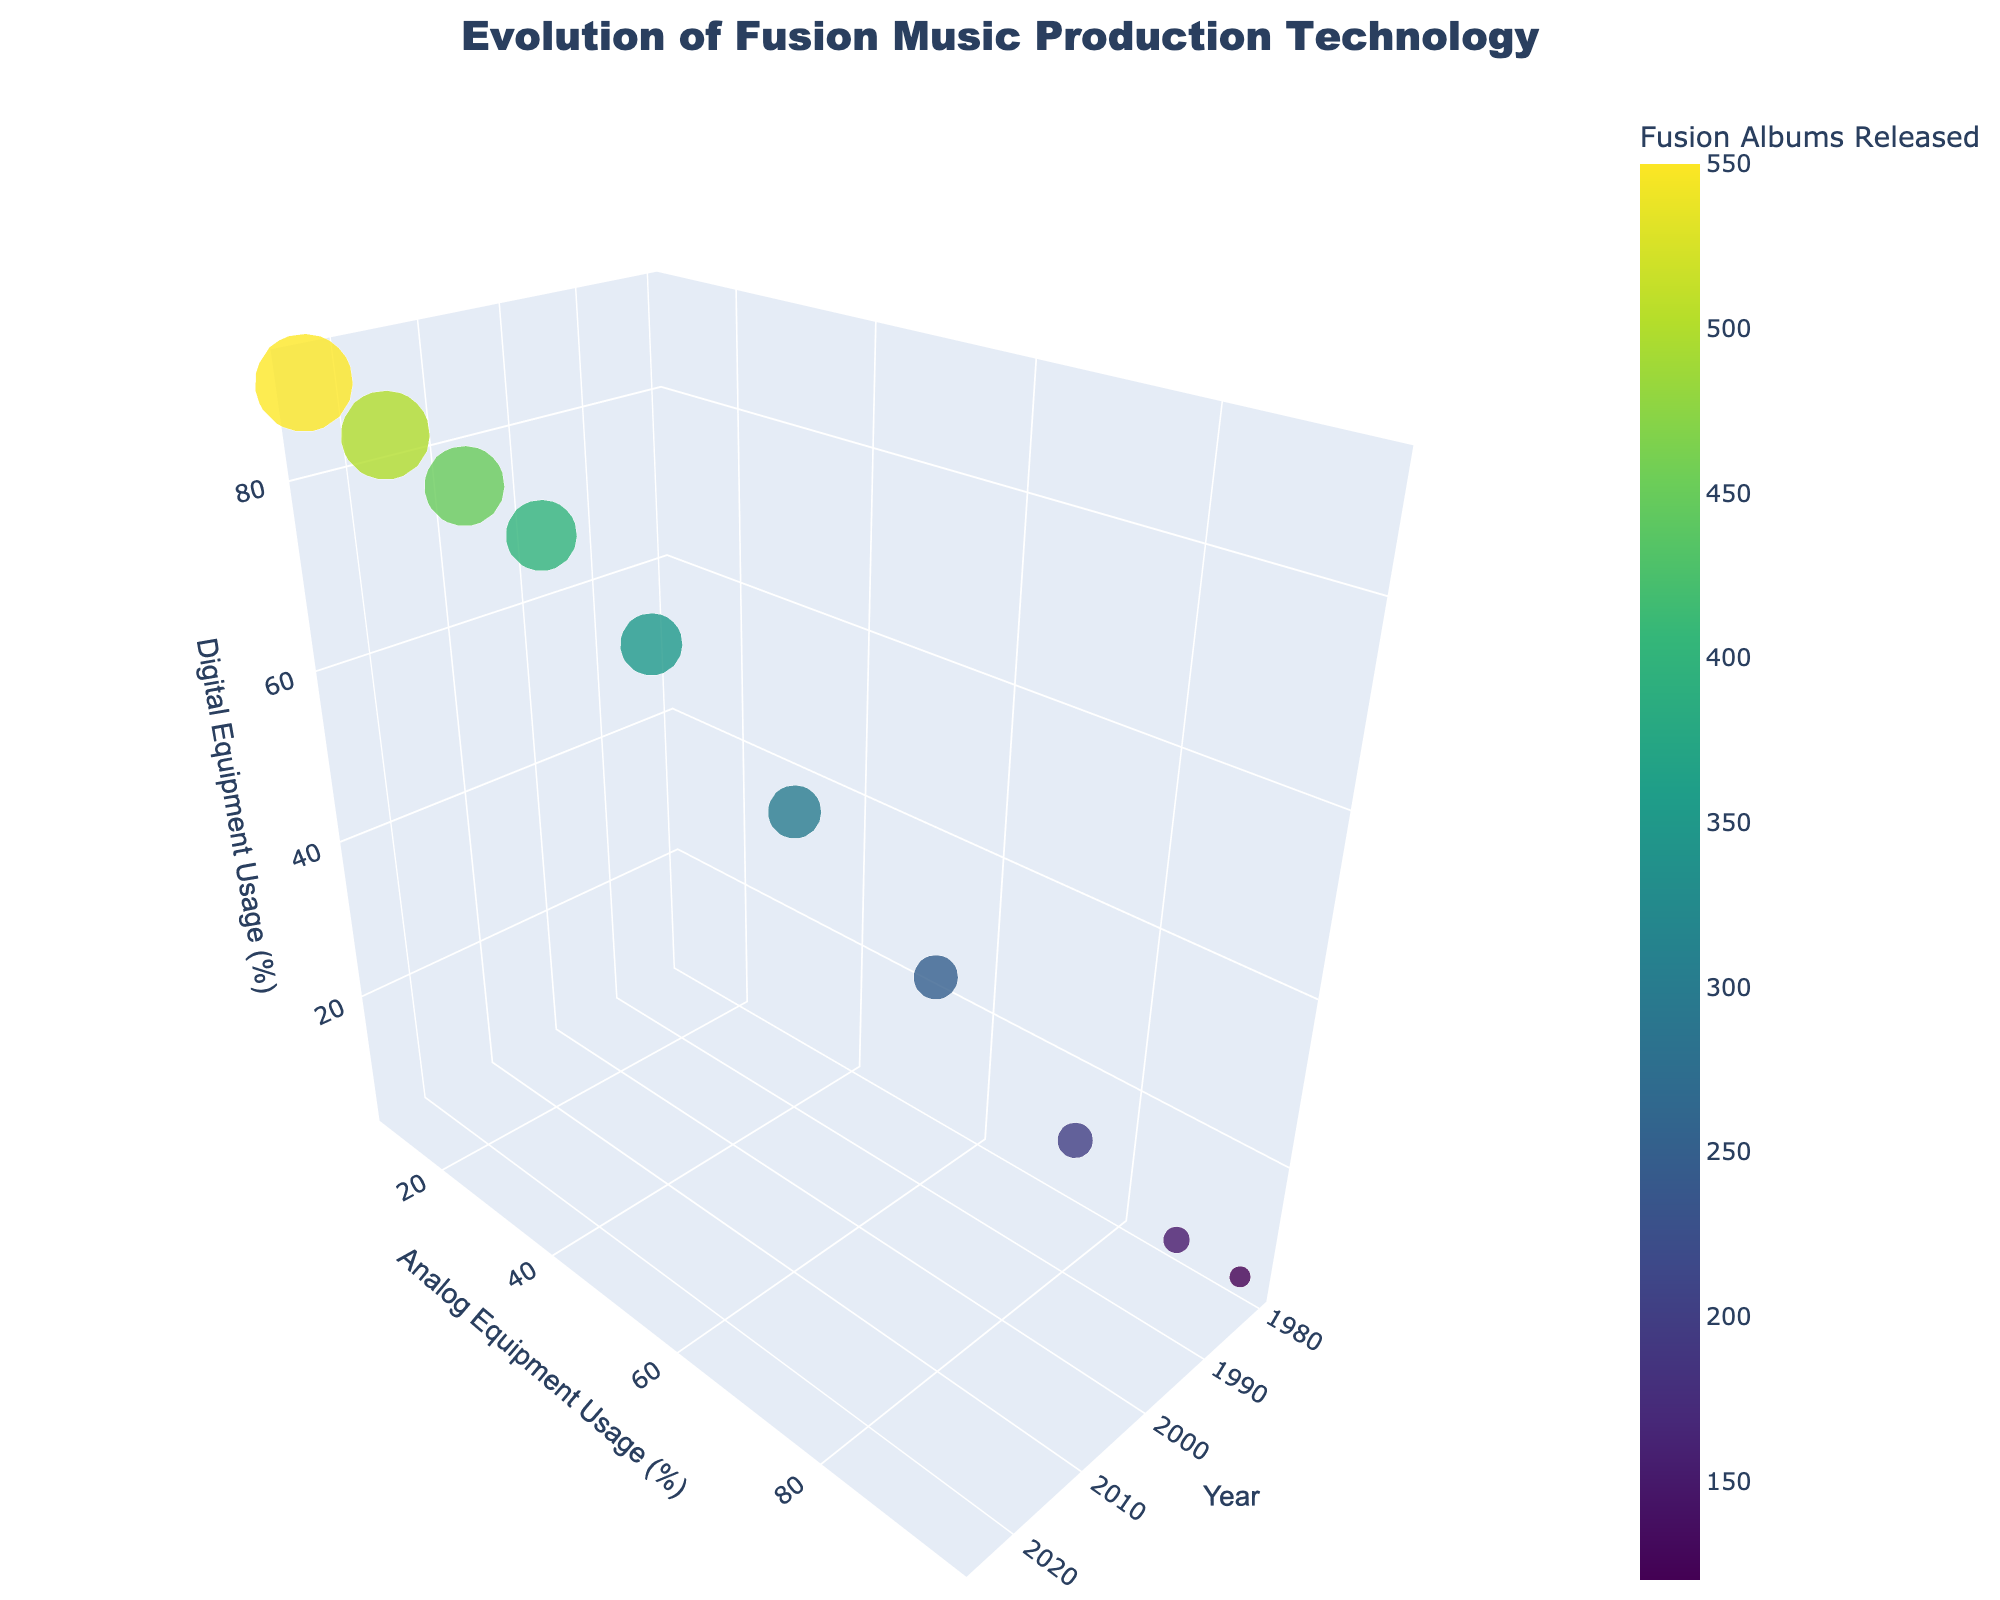What is the title of the 3D plot? The title is positioned at the top center of the plot. It is displayed in a larger font to draw attention. The title provides an overview of the plot's content.
Answer: Evolution of Fusion Music Production Technology How many data points are displayed in the figure? Each data point represents a year from 1980 to 2025. We count the number of years present in the data to determine the total data points.
Answer: 10 What does the size of the markers represent in the plot? The size of the markers is proportional to the number of fusion albums released in a given year. Larger markers indicate more albums.
Answer: Fusion albums released In what year did digital equipment usage surpass analog equipment usage? We look for the year in which the value of digital equipment usage is greater than analog equipment usage on the plot.
Answer: 2000 Which year had the highest number of fusion albums released, and what was that number? Identify the largest marker in size and refer to the color bar scale and the tooltip text.
Answer: 2025, 550 How does the trend in analog equipment usage compare to digital equipment usage over the years? As we move from 1980 to 2025, we observe that analog usage is consistently decreasing while digital usage is increasing. This is a clear inverse relationship.
Answer: Analog usage decreases, digital usage increases Which two years had equal usage percentages of analog and digital equipment, and what was that percentage? We look for when the values for analog and digital equipment usage are the same. This is visually represented when markers align diagonally between the analog and digital axes.
Answer: 2000, 50% How do the colors of the markers indicate the number of fusion albums released? The colors range from lower to higher values along a color scale called 'Viridis'. Lighter colors indicate fewer albums, while darker colors indicate more albums.
Answer: Darker colors indicate more albums 